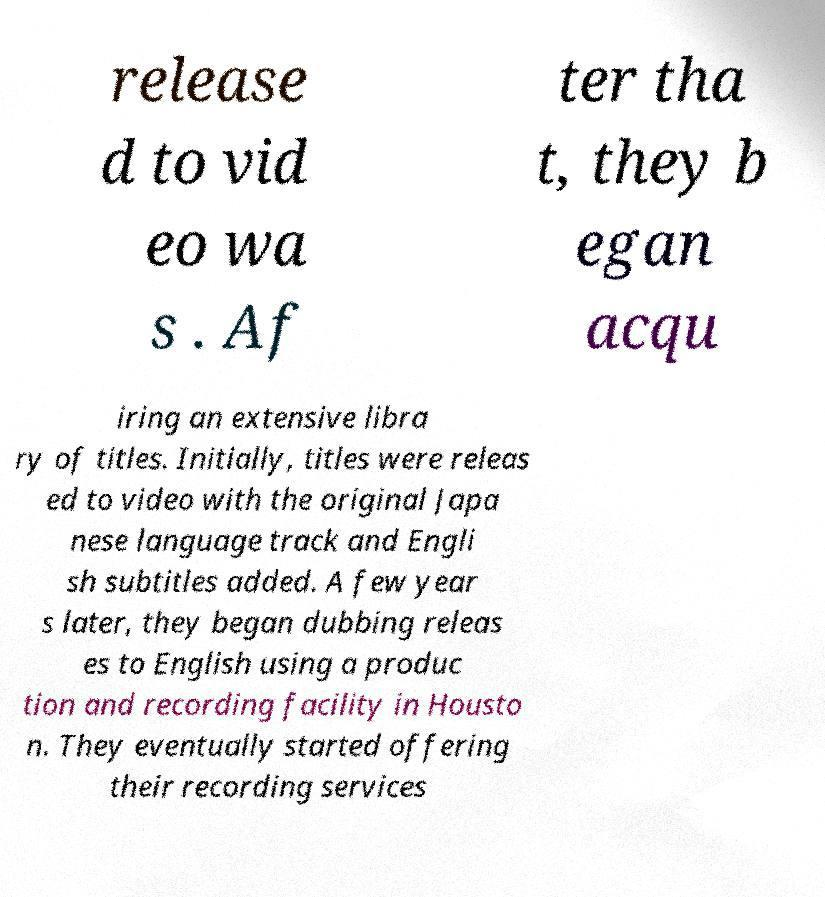For documentation purposes, I need the text within this image transcribed. Could you provide that? release d to vid eo wa s . Af ter tha t, they b egan acqu iring an extensive libra ry of titles. Initially, titles were releas ed to video with the original Japa nese language track and Engli sh subtitles added. A few year s later, they began dubbing releas es to English using a produc tion and recording facility in Housto n. They eventually started offering their recording services 